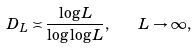Convert formula to latex. <formula><loc_0><loc_0><loc_500><loc_500>D _ { L } \asymp \frac { \log L } { \log \log L } , \quad L \to \infty ,</formula> 